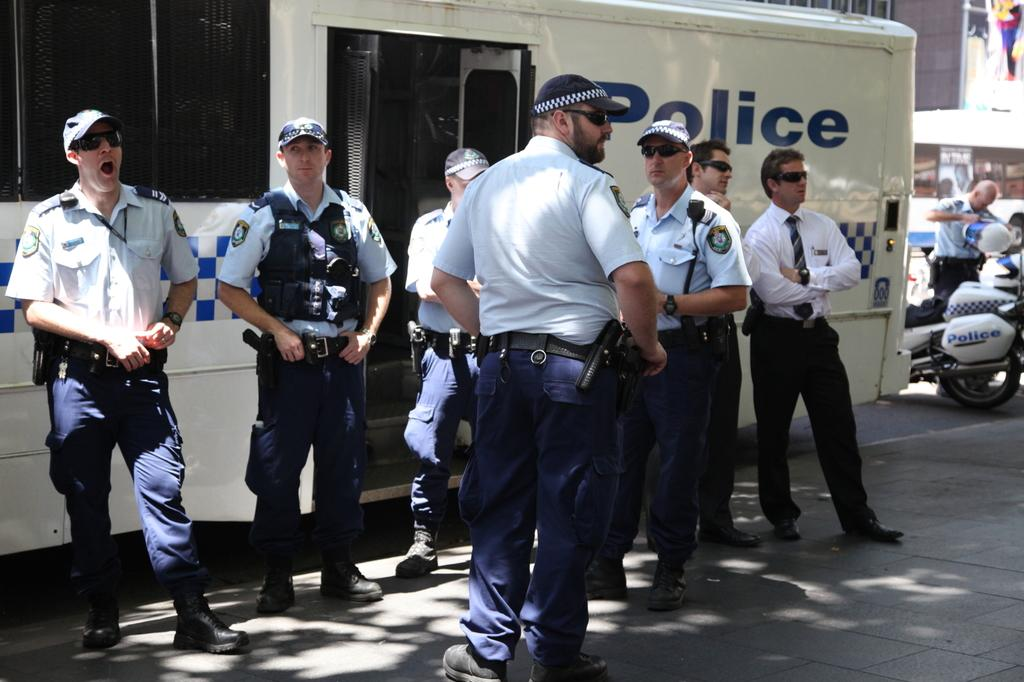How many people are in the image? There is a group of people in the image, but the exact number is not specified. What type of vehicles are present in the image? There are white color buses and motorcycles in the image. What can be seen in the background of the image? There are buildings in the background of the image. What type of collar is being worn by the people in the image? There is no mention of collars in the image, so it cannot be determined if any of the people are wearing them. 